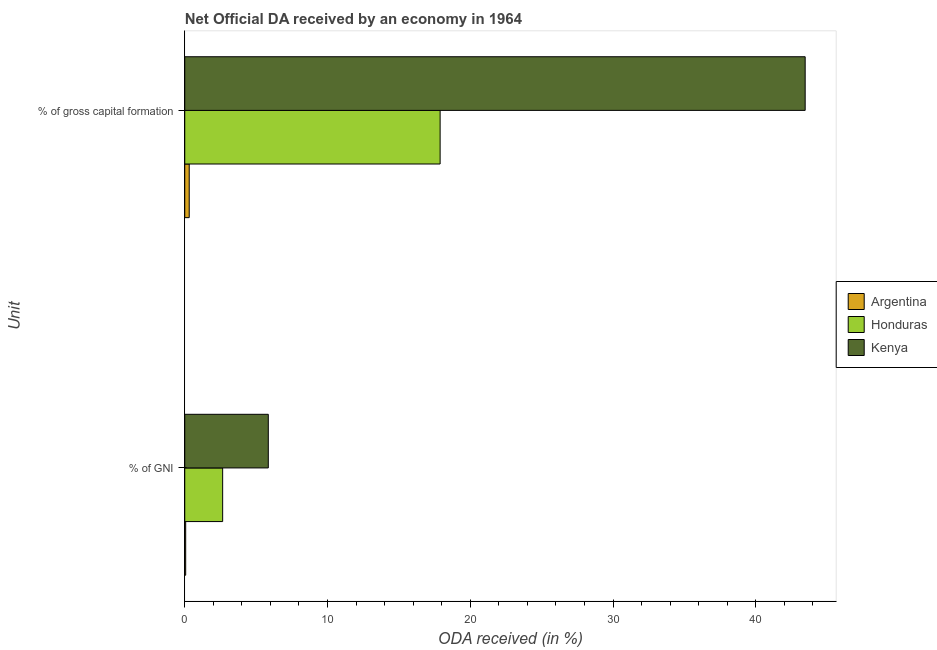Are the number of bars per tick equal to the number of legend labels?
Give a very brief answer. Yes. How many bars are there on the 1st tick from the top?
Offer a terse response. 3. How many bars are there on the 2nd tick from the bottom?
Keep it short and to the point. 3. What is the label of the 2nd group of bars from the top?
Give a very brief answer. % of GNI. What is the oda received as percentage of gni in Kenya?
Your answer should be compact. 5.85. Across all countries, what is the maximum oda received as percentage of gross capital formation?
Offer a terse response. 43.46. Across all countries, what is the minimum oda received as percentage of gross capital formation?
Ensure brevity in your answer.  0.31. In which country was the oda received as percentage of gni maximum?
Your answer should be very brief. Kenya. In which country was the oda received as percentage of gni minimum?
Provide a short and direct response. Argentina. What is the total oda received as percentage of gni in the graph?
Keep it short and to the point. 8.57. What is the difference between the oda received as percentage of gross capital formation in Argentina and that in Kenya?
Offer a terse response. -43.15. What is the difference between the oda received as percentage of gni in Honduras and the oda received as percentage of gross capital formation in Argentina?
Keep it short and to the point. 2.34. What is the average oda received as percentage of gni per country?
Your answer should be compact. 2.86. What is the difference between the oda received as percentage of gross capital formation and oda received as percentage of gni in Honduras?
Keep it short and to the point. 15.23. In how many countries, is the oda received as percentage of gross capital formation greater than 12 %?
Your answer should be compact. 2. What is the ratio of the oda received as percentage of gross capital formation in Argentina to that in Honduras?
Provide a short and direct response. 0.02. Is the oda received as percentage of gni in Argentina less than that in Honduras?
Make the answer very short. Yes. In how many countries, is the oda received as percentage of gross capital formation greater than the average oda received as percentage of gross capital formation taken over all countries?
Offer a terse response. 1. What does the 3rd bar from the top in % of GNI represents?
Your answer should be compact. Argentina. What does the 2nd bar from the bottom in % of gross capital formation represents?
Provide a short and direct response. Honduras. Are all the bars in the graph horizontal?
Provide a short and direct response. Yes. Does the graph contain any zero values?
Give a very brief answer. No. How many legend labels are there?
Give a very brief answer. 3. What is the title of the graph?
Give a very brief answer. Net Official DA received by an economy in 1964. What is the label or title of the X-axis?
Your answer should be very brief. ODA received (in %). What is the label or title of the Y-axis?
Your answer should be compact. Unit. What is the ODA received (in %) in Argentina in % of GNI?
Make the answer very short. 0.07. What is the ODA received (in %) of Honduras in % of GNI?
Keep it short and to the point. 2.66. What is the ODA received (in %) in Kenya in % of GNI?
Give a very brief answer. 5.85. What is the ODA received (in %) in Argentina in % of gross capital formation?
Give a very brief answer. 0.31. What is the ODA received (in %) of Honduras in % of gross capital formation?
Your answer should be very brief. 17.89. What is the ODA received (in %) of Kenya in % of gross capital formation?
Offer a very short reply. 43.46. Across all Unit, what is the maximum ODA received (in %) of Argentina?
Make the answer very short. 0.31. Across all Unit, what is the maximum ODA received (in %) in Honduras?
Your answer should be compact. 17.89. Across all Unit, what is the maximum ODA received (in %) in Kenya?
Your answer should be very brief. 43.46. Across all Unit, what is the minimum ODA received (in %) in Argentina?
Your answer should be compact. 0.07. Across all Unit, what is the minimum ODA received (in %) in Honduras?
Provide a succinct answer. 2.66. Across all Unit, what is the minimum ODA received (in %) in Kenya?
Keep it short and to the point. 5.85. What is the total ODA received (in %) in Argentina in the graph?
Ensure brevity in your answer.  0.38. What is the total ODA received (in %) of Honduras in the graph?
Make the answer very short. 20.54. What is the total ODA received (in %) of Kenya in the graph?
Make the answer very short. 49.31. What is the difference between the ODA received (in %) of Argentina in % of GNI and that in % of gross capital formation?
Provide a succinct answer. -0.25. What is the difference between the ODA received (in %) in Honduras in % of GNI and that in % of gross capital formation?
Provide a short and direct response. -15.23. What is the difference between the ODA received (in %) of Kenya in % of GNI and that in % of gross capital formation?
Your answer should be very brief. -37.61. What is the difference between the ODA received (in %) in Argentina in % of GNI and the ODA received (in %) in Honduras in % of gross capital formation?
Ensure brevity in your answer.  -17.82. What is the difference between the ODA received (in %) of Argentina in % of GNI and the ODA received (in %) of Kenya in % of gross capital formation?
Your response must be concise. -43.4. What is the difference between the ODA received (in %) in Honduras in % of GNI and the ODA received (in %) in Kenya in % of gross capital formation?
Give a very brief answer. -40.81. What is the average ODA received (in %) of Argentina per Unit?
Ensure brevity in your answer.  0.19. What is the average ODA received (in %) in Honduras per Unit?
Provide a short and direct response. 10.27. What is the average ODA received (in %) of Kenya per Unit?
Your response must be concise. 24.66. What is the difference between the ODA received (in %) of Argentina and ODA received (in %) of Honduras in % of GNI?
Provide a short and direct response. -2.59. What is the difference between the ODA received (in %) in Argentina and ODA received (in %) in Kenya in % of GNI?
Keep it short and to the point. -5.79. What is the difference between the ODA received (in %) of Honduras and ODA received (in %) of Kenya in % of GNI?
Make the answer very short. -3.2. What is the difference between the ODA received (in %) in Argentina and ODA received (in %) in Honduras in % of gross capital formation?
Offer a very short reply. -17.58. What is the difference between the ODA received (in %) in Argentina and ODA received (in %) in Kenya in % of gross capital formation?
Make the answer very short. -43.15. What is the difference between the ODA received (in %) of Honduras and ODA received (in %) of Kenya in % of gross capital formation?
Ensure brevity in your answer.  -25.57. What is the ratio of the ODA received (in %) in Argentina in % of GNI to that in % of gross capital formation?
Offer a terse response. 0.21. What is the ratio of the ODA received (in %) in Honduras in % of GNI to that in % of gross capital formation?
Make the answer very short. 0.15. What is the ratio of the ODA received (in %) in Kenya in % of GNI to that in % of gross capital formation?
Your response must be concise. 0.13. What is the difference between the highest and the second highest ODA received (in %) in Argentina?
Keep it short and to the point. 0.25. What is the difference between the highest and the second highest ODA received (in %) of Honduras?
Provide a succinct answer. 15.23. What is the difference between the highest and the second highest ODA received (in %) in Kenya?
Offer a very short reply. 37.61. What is the difference between the highest and the lowest ODA received (in %) in Argentina?
Make the answer very short. 0.25. What is the difference between the highest and the lowest ODA received (in %) in Honduras?
Provide a short and direct response. 15.23. What is the difference between the highest and the lowest ODA received (in %) in Kenya?
Give a very brief answer. 37.61. 